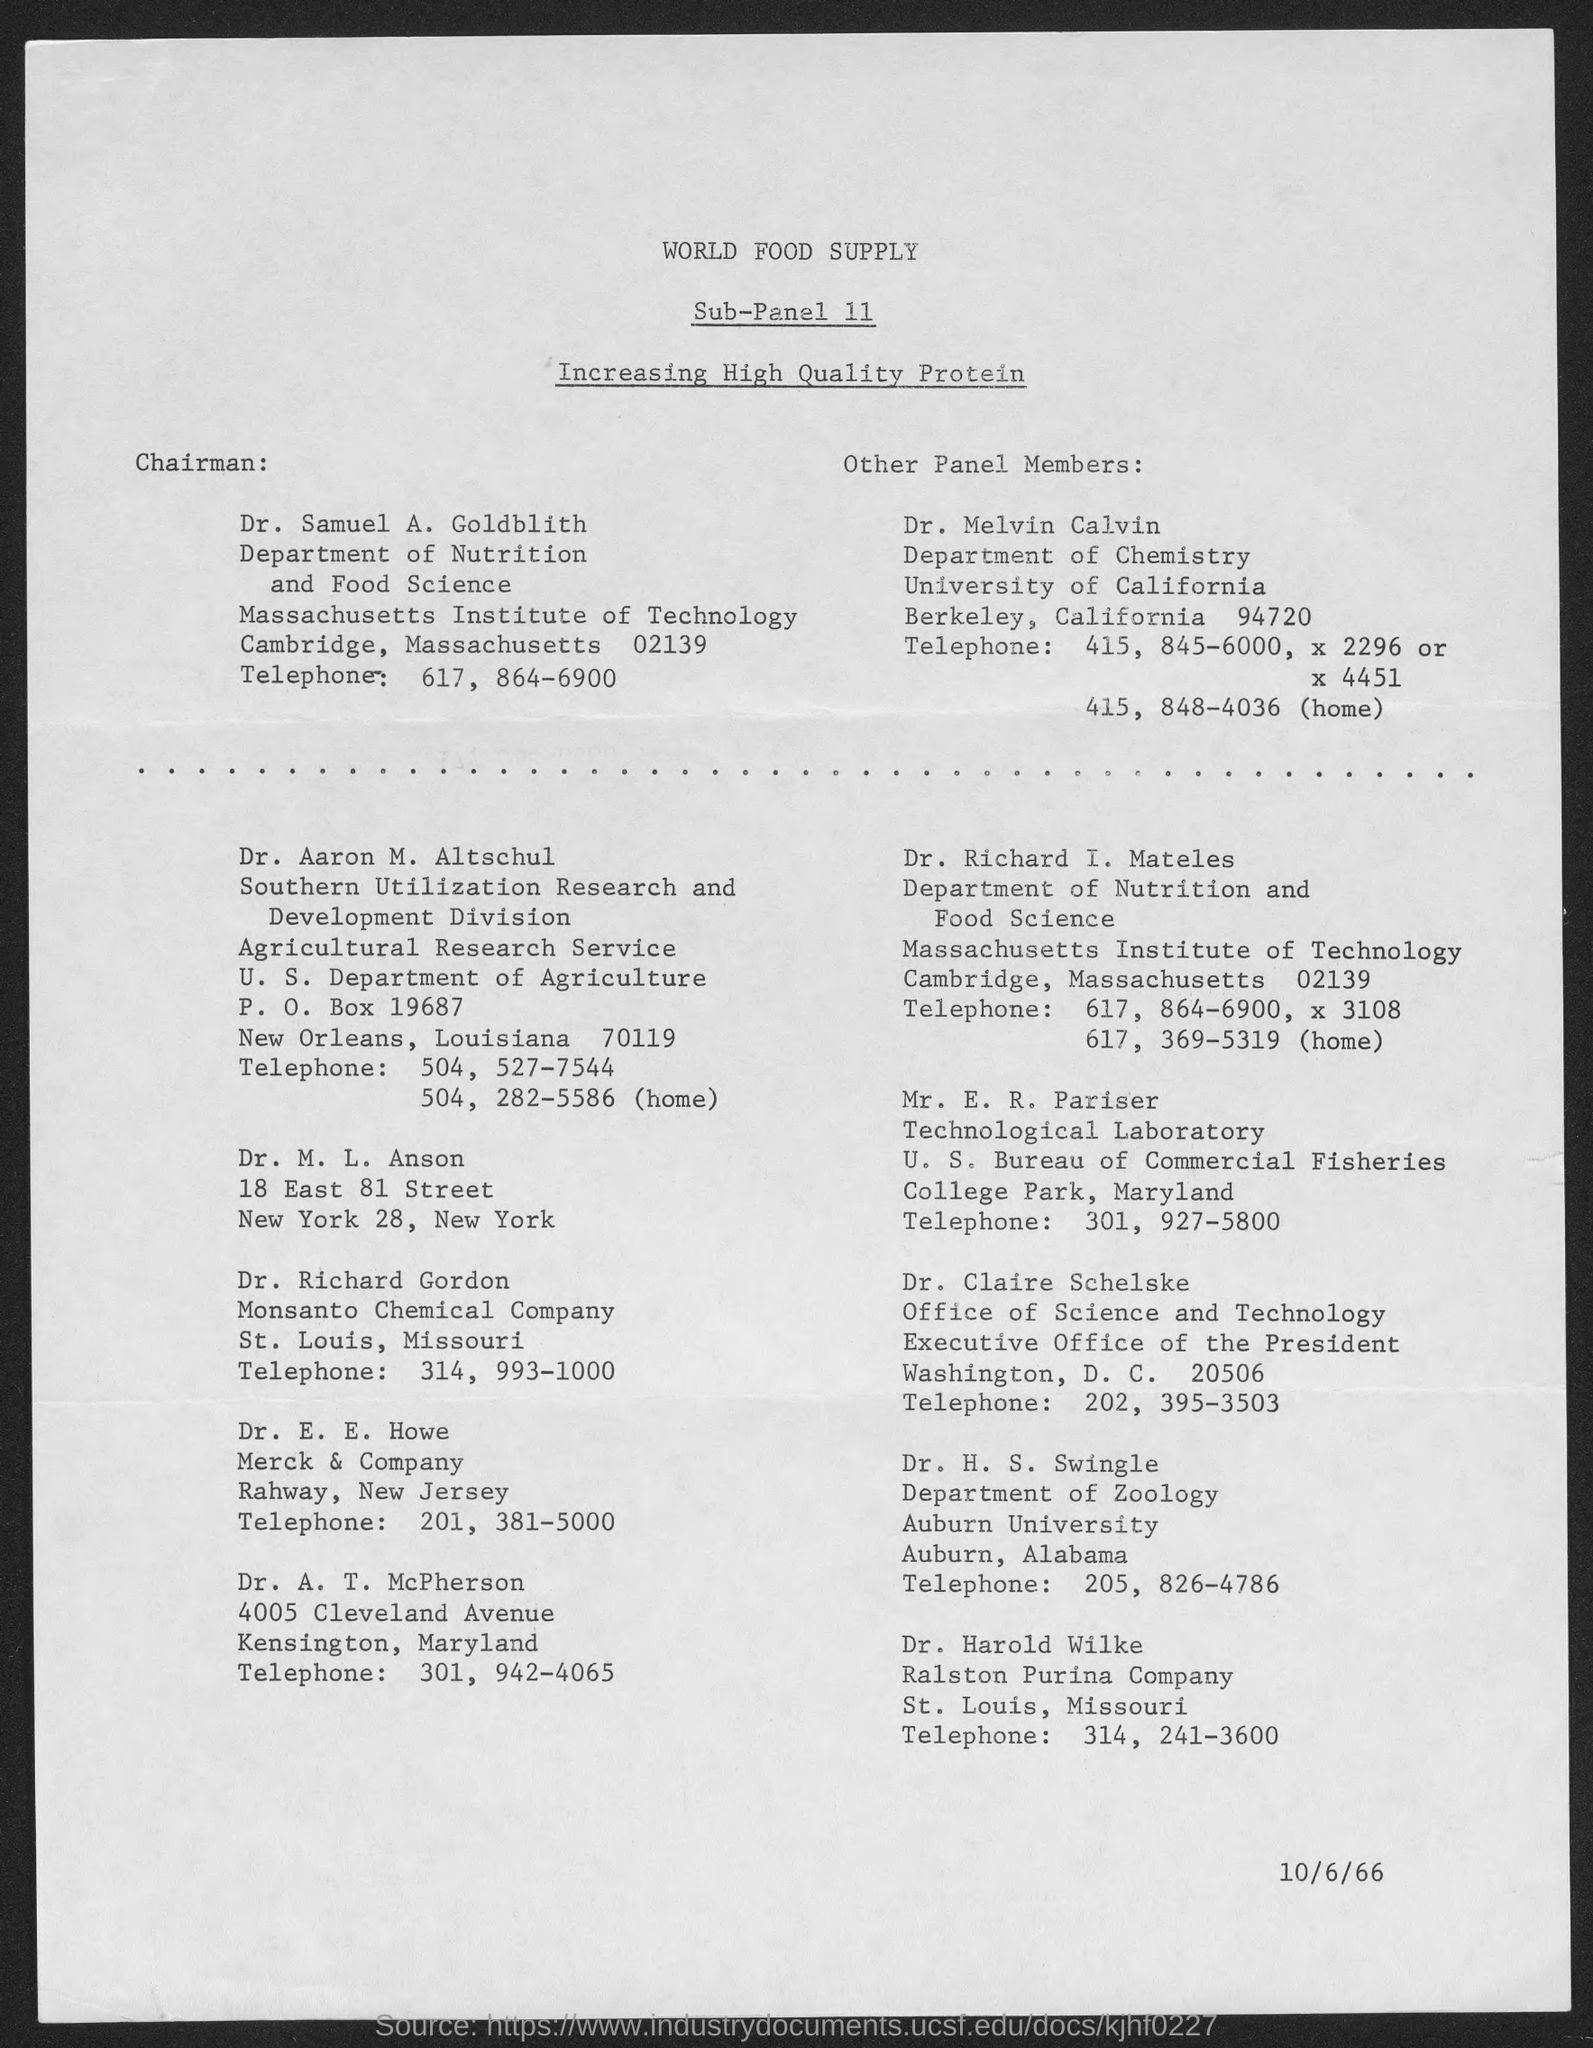Give some essential details in this illustration. On the date of October 6, 1966, the date is noted. Dr. Samuel A. Goldblith is the chairman of the Nutrition and Food Science department. The title of the document is "World Food Supply. 